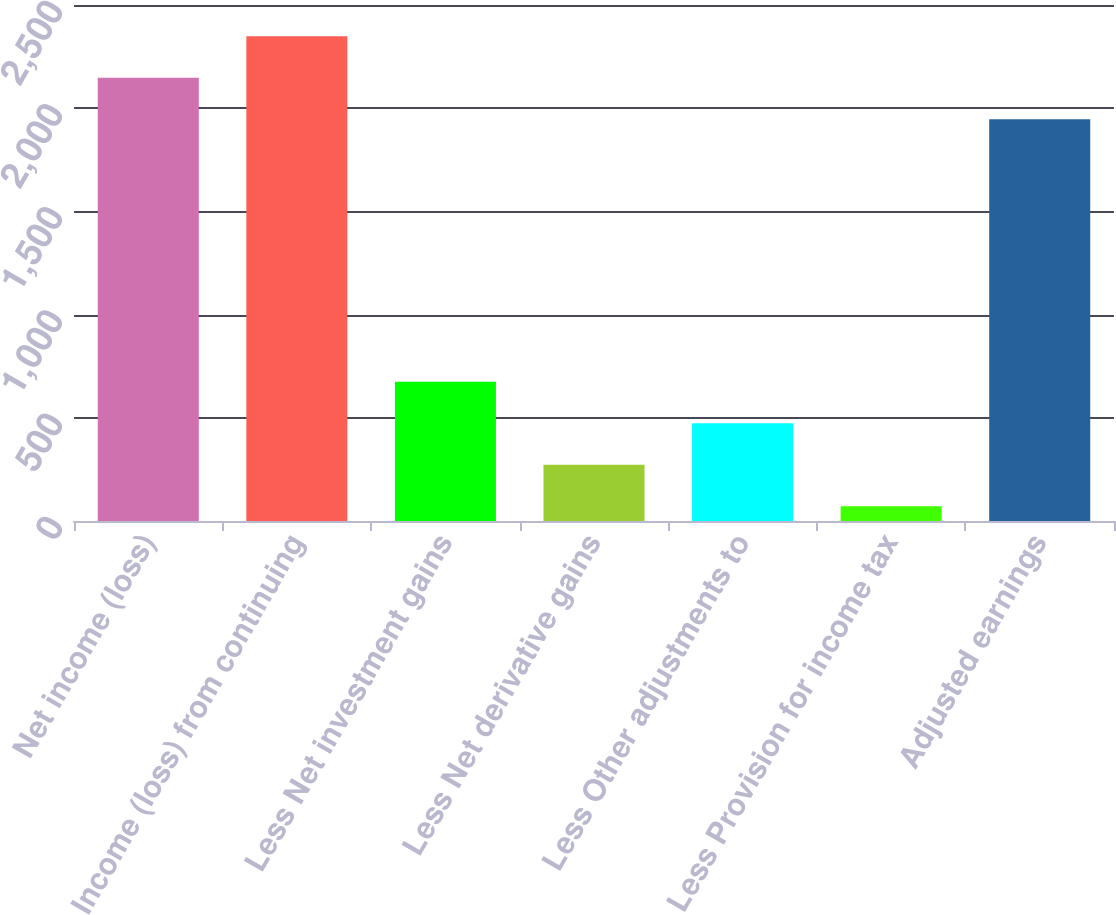Convert chart. <chart><loc_0><loc_0><loc_500><loc_500><bar_chart><fcel>Net income (loss)<fcel>Income (loss) from continuing<fcel>Less Net investment gains<fcel>Less Net derivative gains<fcel>Less Other adjustments to<fcel>Less Provision for income tax<fcel>Adjusted earnings<nl><fcel>2147.8<fcel>2348.6<fcel>674.4<fcel>272.8<fcel>473.6<fcel>72<fcel>1947<nl></chart> 